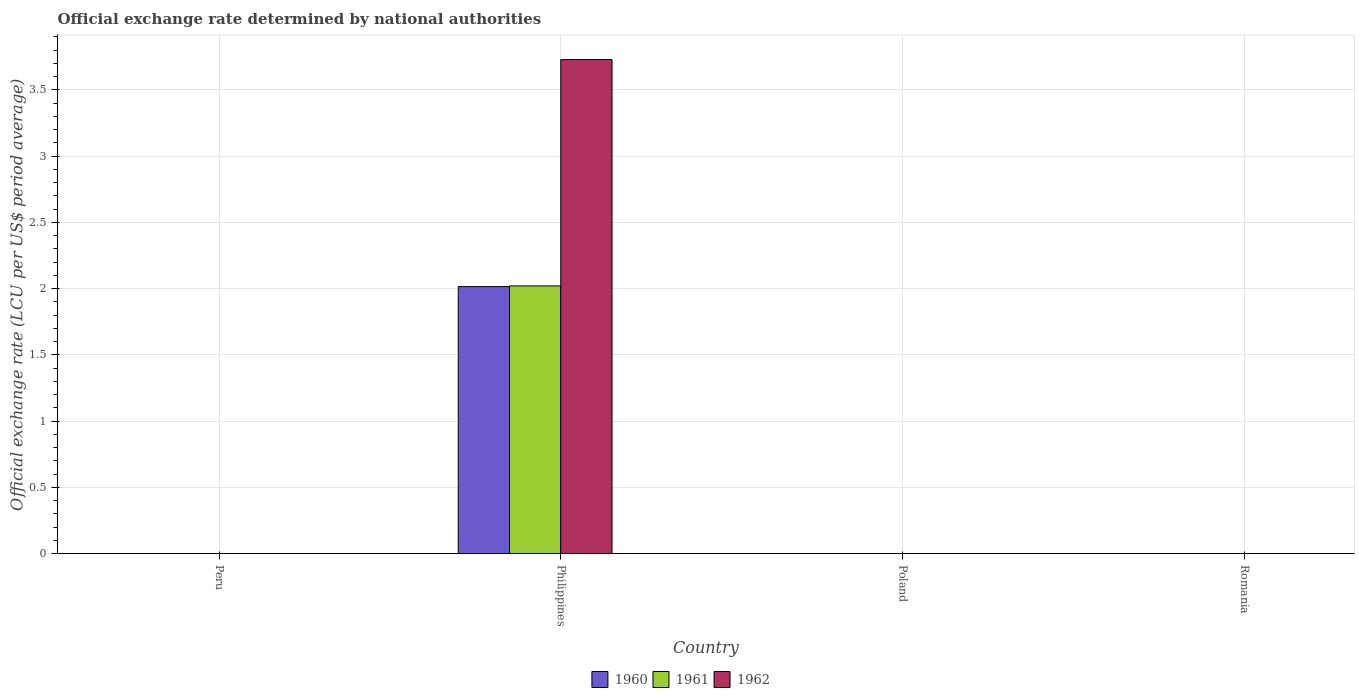How many groups of bars are there?
Make the answer very short. 4. How many bars are there on the 1st tick from the left?
Provide a short and direct response. 3. What is the label of the 4th group of bars from the left?
Ensure brevity in your answer.  Romania. What is the official exchange rate in 1962 in Peru?
Offer a terse response. 2.6819999999e-8. Across all countries, what is the maximum official exchange rate in 1962?
Offer a terse response. 3.73. Across all countries, what is the minimum official exchange rate in 1960?
Your answer should be very brief. 2.729916666591669e-8. In which country was the official exchange rate in 1961 minimum?
Provide a succinct answer. Peru. What is the total official exchange rate in 1961 in the graph?
Your answer should be very brief. 2.02. What is the difference between the official exchange rate in 1961 in Peru and that in Poland?
Provide a short and direct response. -0. What is the difference between the official exchange rate in 1960 in Poland and the official exchange rate in 1962 in Peru?
Offer a terse response. 0. What is the average official exchange rate in 1962 per country?
Keep it short and to the point. 0.93. What is the difference between the official exchange rate of/in 1962 and official exchange rate of/in 1960 in Poland?
Give a very brief answer. 0. What is the ratio of the official exchange rate in 1960 in Philippines to that in Romania?
Provide a succinct answer. 3358.33. Is the difference between the official exchange rate in 1962 in Poland and Romania greater than the difference between the official exchange rate in 1960 in Poland and Romania?
Provide a succinct answer. No. What is the difference between the highest and the second highest official exchange rate in 1962?
Keep it short and to the point. -3.73. What is the difference between the highest and the lowest official exchange rate in 1962?
Offer a very short reply. 3.73. In how many countries, is the official exchange rate in 1961 greater than the average official exchange rate in 1961 taken over all countries?
Provide a short and direct response. 1. Is the sum of the official exchange rate in 1962 in Philippines and Romania greater than the maximum official exchange rate in 1961 across all countries?
Offer a terse response. Yes. What does the 1st bar from the left in Romania represents?
Offer a terse response. 1960. What does the 2nd bar from the right in Poland represents?
Give a very brief answer. 1961. How many countries are there in the graph?
Your answer should be compact. 4. Are the values on the major ticks of Y-axis written in scientific E-notation?
Your answer should be very brief. No. Where does the legend appear in the graph?
Provide a succinct answer. Bottom center. How many legend labels are there?
Provide a succinct answer. 3. How are the legend labels stacked?
Provide a short and direct response. Horizontal. What is the title of the graph?
Provide a short and direct response. Official exchange rate determined by national authorities. What is the label or title of the Y-axis?
Offer a very short reply. Official exchange rate (LCU per US$ period average). What is the Official exchange rate (LCU per US$ period average) in 1960 in Peru?
Make the answer very short. 2.729916666591669e-8. What is the Official exchange rate (LCU per US$ period average) in 1961 in Peru?
Your answer should be very brief. 2.681666666575e-8. What is the Official exchange rate (LCU per US$ period average) of 1962 in Peru?
Give a very brief answer. 2.6819999999e-8. What is the Official exchange rate (LCU per US$ period average) in 1960 in Philippines?
Give a very brief answer. 2.01. What is the Official exchange rate (LCU per US$ period average) of 1961 in Philippines?
Keep it short and to the point. 2.02. What is the Official exchange rate (LCU per US$ period average) in 1962 in Philippines?
Offer a very short reply. 3.73. What is the Official exchange rate (LCU per US$ period average) of 1960 in Poland?
Offer a very short reply. 0. What is the Official exchange rate (LCU per US$ period average) in 1961 in Poland?
Offer a terse response. 0. What is the Official exchange rate (LCU per US$ period average) in 1962 in Poland?
Give a very brief answer. 0. What is the Official exchange rate (LCU per US$ period average) of 1960 in Romania?
Ensure brevity in your answer.  0. What is the Official exchange rate (LCU per US$ period average) in 1961 in Romania?
Your answer should be very brief. 0. What is the Official exchange rate (LCU per US$ period average) in 1962 in Romania?
Keep it short and to the point. 0. Across all countries, what is the maximum Official exchange rate (LCU per US$ period average) in 1960?
Give a very brief answer. 2.01. Across all countries, what is the maximum Official exchange rate (LCU per US$ period average) of 1961?
Your response must be concise. 2.02. Across all countries, what is the maximum Official exchange rate (LCU per US$ period average) in 1962?
Your response must be concise. 3.73. Across all countries, what is the minimum Official exchange rate (LCU per US$ period average) of 1960?
Offer a very short reply. 2.729916666591669e-8. Across all countries, what is the minimum Official exchange rate (LCU per US$ period average) in 1961?
Provide a short and direct response. 2.681666666575e-8. Across all countries, what is the minimum Official exchange rate (LCU per US$ period average) of 1962?
Your answer should be very brief. 2.6819999999e-8. What is the total Official exchange rate (LCU per US$ period average) of 1960 in the graph?
Give a very brief answer. 2.02. What is the total Official exchange rate (LCU per US$ period average) of 1961 in the graph?
Your answer should be very brief. 2.02. What is the total Official exchange rate (LCU per US$ period average) of 1962 in the graph?
Offer a very short reply. 3.73. What is the difference between the Official exchange rate (LCU per US$ period average) in 1960 in Peru and that in Philippines?
Provide a short and direct response. -2.02. What is the difference between the Official exchange rate (LCU per US$ period average) in 1961 in Peru and that in Philippines?
Offer a terse response. -2.02. What is the difference between the Official exchange rate (LCU per US$ period average) of 1962 in Peru and that in Philippines?
Your response must be concise. -3.73. What is the difference between the Official exchange rate (LCU per US$ period average) in 1960 in Peru and that in Poland?
Offer a very short reply. -0. What is the difference between the Official exchange rate (LCU per US$ period average) in 1961 in Peru and that in Poland?
Keep it short and to the point. -0. What is the difference between the Official exchange rate (LCU per US$ period average) of 1962 in Peru and that in Poland?
Your answer should be very brief. -0. What is the difference between the Official exchange rate (LCU per US$ period average) of 1960 in Peru and that in Romania?
Give a very brief answer. -0. What is the difference between the Official exchange rate (LCU per US$ period average) in 1961 in Peru and that in Romania?
Keep it short and to the point. -0. What is the difference between the Official exchange rate (LCU per US$ period average) in 1962 in Peru and that in Romania?
Give a very brief answer. -0. What is the difference between the Official exchange rate (LCU per US$ period average) in 1960 in Philippines and that in Poland?
Provide a succinct answer. 2.01. What is the difference between the Official exchange rate (LCU per US$ period average) of 1961 in Philippines and that in Poland?
Your answer should be compact. 2.02. What is the difference between the Official exchange rate (LCU per US$ period average) of 1962 in Philippines and that in Poland?
Offer a terse response. 3.73. What is the difference between the Official exchange rate (LCU per US$ period average) of 1960 in Philippines and that in Romania?
Keep it short and to the point. 2.01. What is the difference between the Official exchange rate (LCU per US$ period average) in 1961 in Philippines and that in Romania?
Ensure brevity in your answer.  2.02. What is the difference between the Official exchange rate (LCU per US$ period average) in 1962 in Philippines and that in Romania?
Your answer should be compact. 3.73. What is the difference between the Official exchange rate (LCU per US$ period average) of 1960 in Poland and that in Romania?
Provide a short and direct response. -0. What is the difference between the Official exchange rate (LCU per US$ period average) of 1961 in Poland and that in Romania?
Make the answer very short. -0. What is the difference between the Official exchange rate (LCU per US$ period average) in 1962 in Poland and that in Romania?
Make the answer very short. -0. What is the difference between the Official exchange rate (LCU per US$ period average) of 1960 in Peru and the Official exchange rate (LCU per US$ period average) of 1961 in Philippines?
Offer a very short reply. -2.02. What is the difference between the Official exchange rate (LCU per US$ period average) in 1960 in Peru and the Official exchange rate (LCU per US$ period average) in 1962 in Philippines?
Your answer should be compact. -3.73. What is the difference between the Official exchange rate (LCU per US$ period average) of 1961 in Peru and the Official exchange rate (LCU per US$ period average) of 1962 in Philippines?
Offer a terse response. -3.73. What is the difference between the Official exchange rate (LCU per US$ period average) of 1960 in Peru and the Official exchange rate (LCU per US$ period average) of 1961 in Poland?
Your answer should be very brief. -0. What is the difference between the Official exchange rate (LCU per US$ period average) in 1960 in Peru and the Official exchange rate (LCU per US$ period average) in 1962 in Poland?
Your response must be concise. -0. What is the difference between the Official exchange rate (LCU per US$ period average) in 1961 in Peru and the Official exchange rate (LCU per US$ period average) in 1962 in Poland?
Offer a terse response. -0. What is the difference between the Official exchange rate (LCU per US$ period average) in 1960 in Peru and the Official exchange rate (LCU per US$ period average) in 1961 in Romania?
Give a very brief answer. -0. What is the difference between the Official exchange rate (LCU per US$ period average) of 1960 in Peru and the Official exchange rate (LCU per US$ period average) of 1962 in Romania?
Make the answer very short. -0. What is the difference between the Official exchange rate (LCU per US$ period average) of 1961 in Peru and the Official exchange rate (LCU per US$ period average) of 1962 in Romania?
Provide a succinct answer. -0. What is the difference between the Official exchange rate (LCU per US$ period average) in 1960 in Philippines and the Official exchange rate (LCU per US$ period average) in 1961 in Poland?
Make the answer very short. 2.01. What is the difference between the Official exchange rate (LCU per US$ period average) in 1960 in Philippines and the Official exchange rate (LCU per US$ period average) in 1962 in Poland?
Offer a very short reply. 2.01. What is the difference between the Official exchange rate (LCU per US$ period average) of 1961 in Philippines and the Official exchange rate (LCU per US$ period average) of 1962 in Poland?
Your response must be concise. 2.02. What is the difference between the Official exchange rate (LCU per US$ period average) in 1960 in Philippines and the Official exchange rate (LCU per US$ period average) in 1961 in Romania?
Offer a terse response. 2.01. What is the difference between the Official exchange rate (LCU per US$ period average) in 1960 in Philippines and the Official exchange rate (LCU per US$ period average) in 1962 in Romania?
Provide a succinct answer. 2.01. What is the difference between the Official exchange rate (LCU per US$ period average) of 1961 in Philippines and the Official exchange rate (LCU per US$ period average) of 1962 in Romania?
Give a very brief answer. 2.02. What is the difference between the Official exchange rate (LCU per US$ period average) in 1960 in Poland and the Official exchange rate (LCU per US$ period average) in 1961 in Romania?
Provide a short and direct response. -0. What is the difference between the Official exchange rate (LCU per US$ period average) in 1960 in Poland and the Official exchange rate (LCU per US$ period average) in 1962 in Romania?
Keep it short and to the point. -0. What is the difference between the Official exchange rate (LCU per US$ period average) in 1961 in Poland and the Official exchange rate (LCU per US$ period average) in 1962 in Romania?
Your response must be concise. -0. What is the average Official exchange rate (LCU per US$ period average) of 1960 per country?
Provide a succinct answer. 0.5. What is the average Official exchange rate (LCU per US$ period average) of 1961 per country?
Your response must be concise. 0.51. What is the average Official exchange rate (LCU per US$ period average) of 1962 per country?
Your answer should be compact. 0.93. What is the difference between the Official exchange rate (LCU per US$ period average) in 1960 and Official exchange rate (LCU per US$ period average) in 1961 in Peru?
Your response must be concise. 0. What is the difference between the Official exchange rate (LCU per US$ period average) in 1961 and Official exchange rate (LCU per US$ period average) in 1962 in Peru?
Your answer should be compact. -0. What is the difference between the Official exchange rate (LCU per US$ period average) of 1960 and Official exchange rate (LCU per US$ period average) of 1961 in Philippines?
Provide a short and direct response. -0.01. What is the difference between the Official exchange rate (LCU per US$ period average) in 1960 and Official exchange rate (LCU per US$ period average) in 1962 in Philippines?
Your answer should be compact. -1.71. What is the difference between the Official exchange rate (LCU per US$ period average) of 1961 and Official exchange rate (LCU per US$ period average) of 1962 in Philippines?
Give a very brief answer. -1.71. What is the difference between the Official exchange rate (LCU per US$ period average) of 1960 and Official exchange rate (LCU per US$ period average) of 1961 in Poland?
Your response must be concise. 0. What is the difference between the Official exchange rate (LCU per US$ period average) of 1960 and Official exchange rate (LCU per US$ period average) of 1962 in Poland?
Ensure brevity in your answer.  0. What is the ratio of the Official exchange rate (LCU per US$ period average) of 1961 in Peru to that in Philippines?
Give a very brief answer. 0. What is the ratio of the Official exchange rate (LCU per US$ period average) of 1962 in Peru to that in Philippines?
Keep it short and to the point. 0. What is the ratio of the Official exchange rate (LCU per US$ period average) in 1962 in Peru to that in Poland?
Offer a terse response. 0. What is the ratio of the Official exchange rate (LCU per US$ period average) in 1961 in Peru to that in Romania?
Keep it short and to the point. 0. What is the ratio of the Official exchange rate (LCU per US$ period average) of 1960 in Philippines to that in Poland?
Provide a succinct answer. 5037.5. What is the ratio of the Official exchange rate (LCU per US$ period average) of 1961 in Philippines to that in Poland?
Make the answer very short. 5049.99. What is the ratio of the Official exchange rate (LCU per US$ period average) of 1962 in Philippines to that in Poland?
Your response must be concise. 9319.63. What is the ratio of the Official exchange rate (LCU per US$ period average) in 1960 in Philippines to that in Romania?
Your answer should be compact. 3358.33. What is the ratio of the Official exchange rate (LCU per US$ period average) of 1961 in Philippines to that in Romania?
Provide a short and direct response. 3366.66. What is the ratio of the Official exchange rate (LCU per US$ period average) in 1962 in Philippines to that in Romania?
Provide a short and direct response. 6213.09. What is the difference between the highest and the second highest Official exchange rate (LCU per US$ period average) of 1960?
Make the answer very short. 2.01. What is the difference between the highest and the second highest Official exchange rate (LCU per US$ period average) in 1961?
Your answer should be compact. 2.02. What is the difference between the highest and the second highest Official exchange rate (LCU per US$ period average) in 1962?
Provide a short and direct response. 3.73. What is the difference between the highest and the lowest Official exchange rate (LCU per US$ period average) of 1960?
Provide a short and direct response. 2.02. What is the difference between the highest and the lowest Official exchange rate (LCU per US$ period average) of 1961?
Your answer should be very brief. 2.02. What is the difference between the highest and the lowest Official exchange rate (LCU per US$ period average) of 1962?
Ensure brevity in your answer.  3.73. 